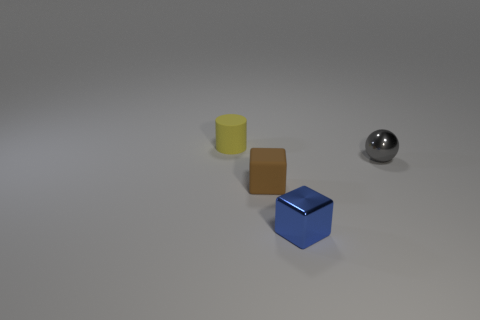Add 1 small yellow blocks. How many objects exist? 5 Subtract all cylinders. How many objects are left? 3 Add 3 tiny yellow cylinders. How many tiny yellow cylinders exist? 4 Subtract 1 yellow cylinders. How many objects are left? 3 Subtract all matte balls. Subtract all tiny yellow cylinders. How many objects are left? 3 Add 1 brown things. How many brown things are left? 2 